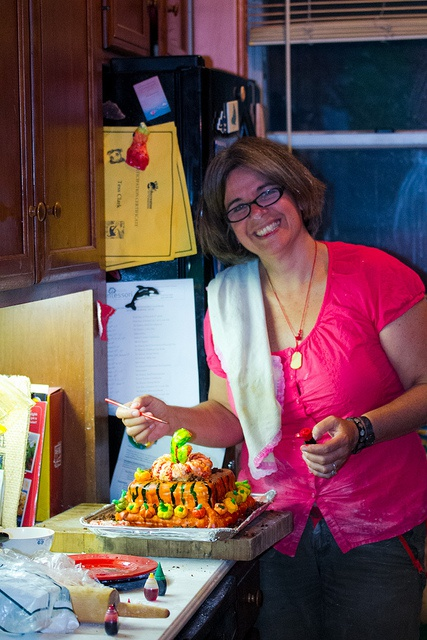Describe the objects in this image and their specific colors. I can see people in maroon, black, brown, and purple tones, refrigerator in maroon, black, lightblue, tan, and darkgray tones, cake in maroon, orange, red, and brown tones, book in maroon, beige, khaki, and darkgray tones, and book in maroon, olive, and white tones in this image. 